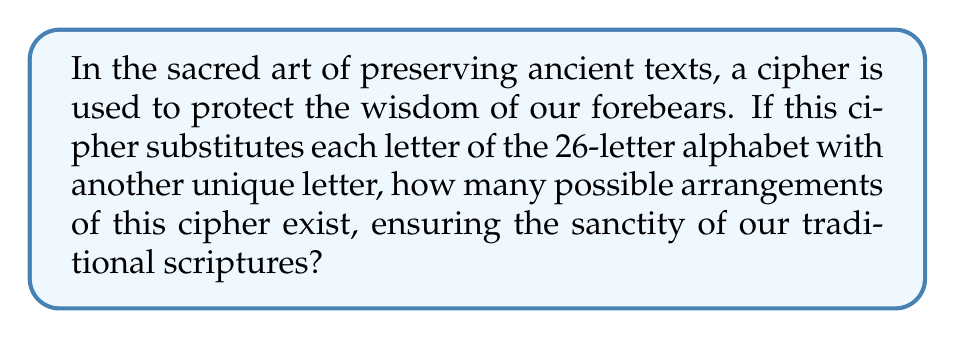Provide a solution to this math problem. To determine the number of possible permutations in a simple substitution cipher for a 26-letter alphabet, we follow these steps:

1. For the first letter, we have 26 choices.
2. For the second letter, we have 25 remaining choices.
3. For the third letter, we have 24 remaining choices.
4. This pattern continues until we reach the last letter, where we have only 1 choice left.

This scenario represents a permutation of 26 elements. The formula for permutations is:

$$P(n) = n!$$

Where $n$ is the number of elements (in this case, 26 letters).

Therefore, the number of possible permutations is:

$$26! = 26 \times 25 \times 24 \times ... \times 3 \times 2 \times 1$$

Calculating this:

$$26! = 403,291,461,126,605,635,584,000,000$$

This immense number represents the multitude of ways our sacred texts can be protected through this cipher, preserving their sanctity for generations to come.
Answer: $26! = 403,291,461,126,605,635,584,000,000$ 